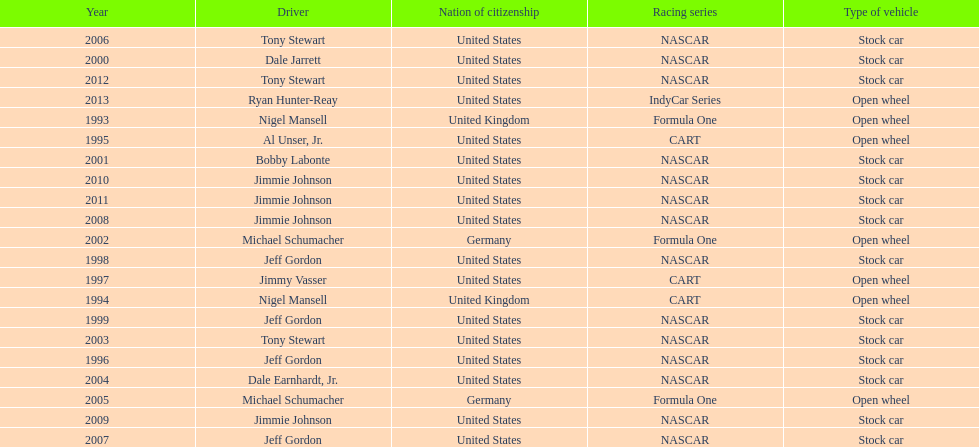Which racing series has the highest total of winners? NASCAR. 